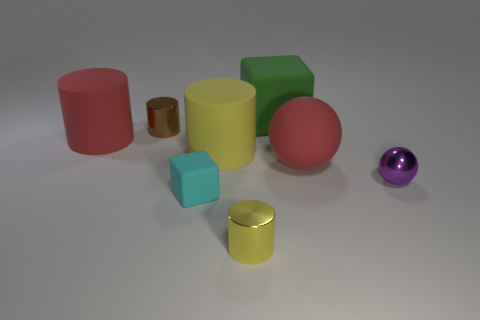Is there any other thing of the same color as the large matte sphere? Yes, there is a smaller sphere that appears to have the same or a very similar purple shade as the large matte sphere. 